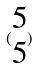<formula> <loc_0><loc_0><loc_500><loc_500>( \begin{matrix} 5 \\ 5 \end{matrix} )</formula> 